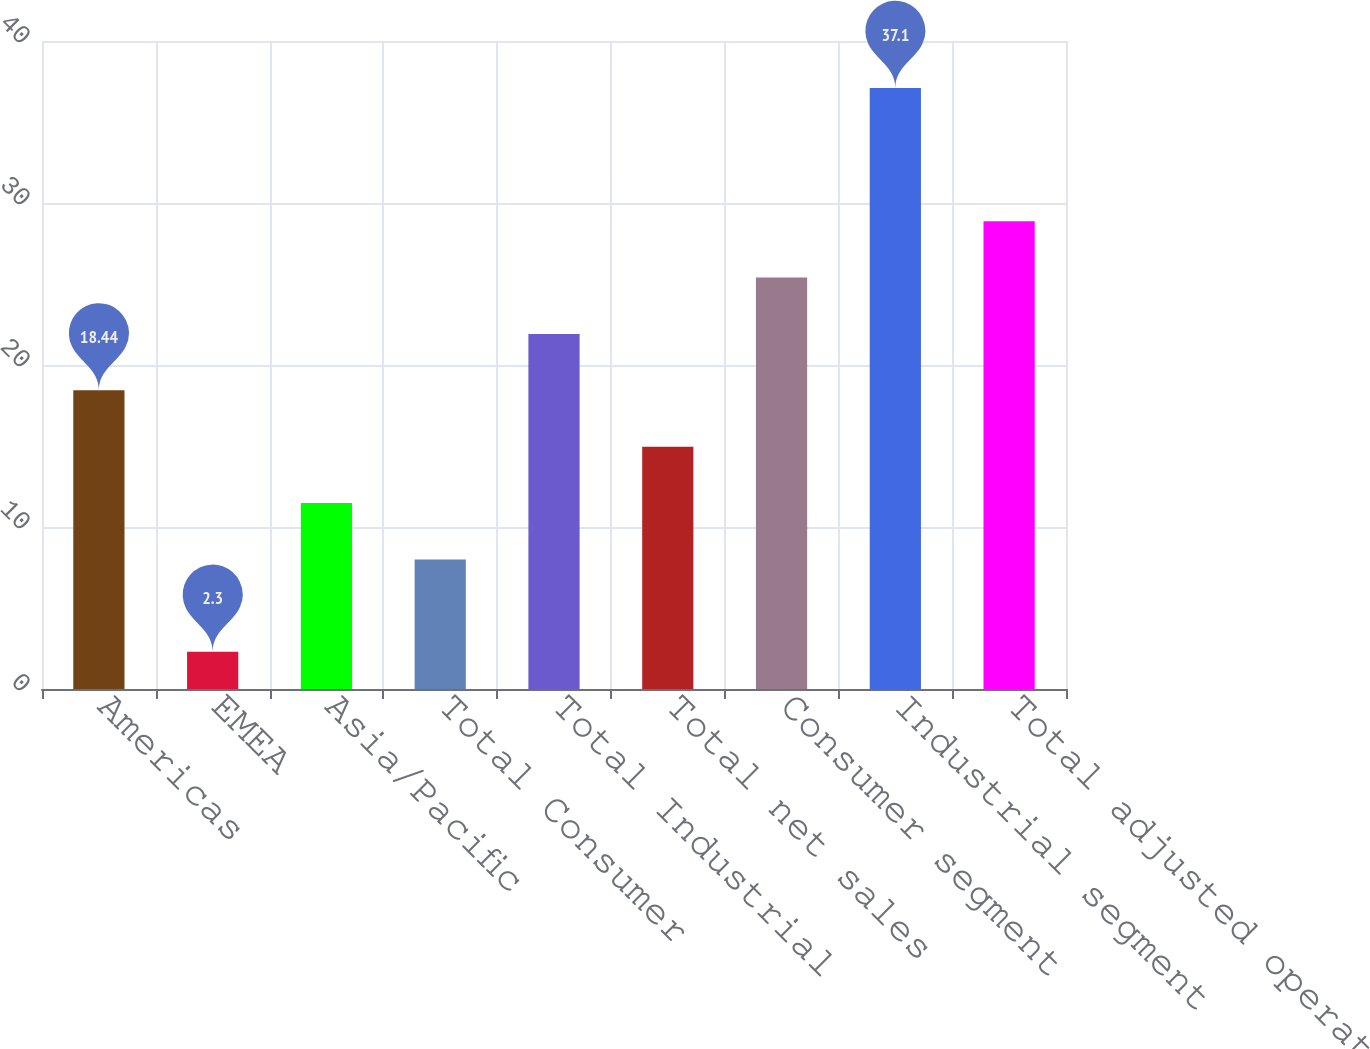Convert chart to OTSL. <chart><loc_0><loc_0><loc_500><loc_500><bar_chart><fcel>Americas<fcel>EMEA<fcel>Asia/Pacific<fcel>Total Consumer<fcel>Total Industrial<fcel>Total net sales<fcel>Consumer segment<fcel>Industrial segment<fcel>Total adjusted operating<nl><fcel>18.44<fcel>2.3<fcel>11.48<fcel>8<fcel>21.92<fcel>14.96<fcel>25.4<fcel>37.1<fcel>28.88<nl></chart> 